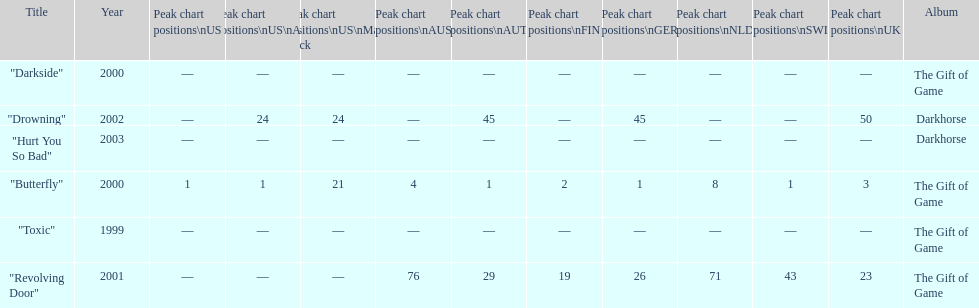When did "drowning" peak at 24 in the us alternate group? 2002. 